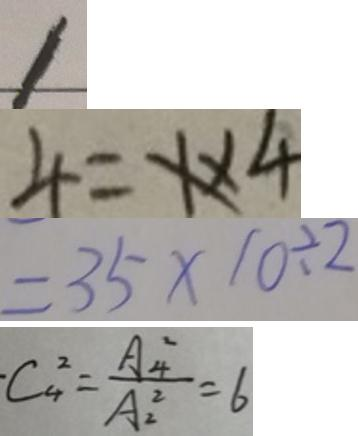<formula> <loc_0><loc_0><loc_500><loc_500>1 
 4 = x \times 4 
 = 3 5 \times 1 0 \div 2 
 \cdot C _ { 4 } ^ { 2 } = \frac { A _ { 4 } ^ { 2 } } { A _ { 2 } ^ { 2 } } = 6</formula> 